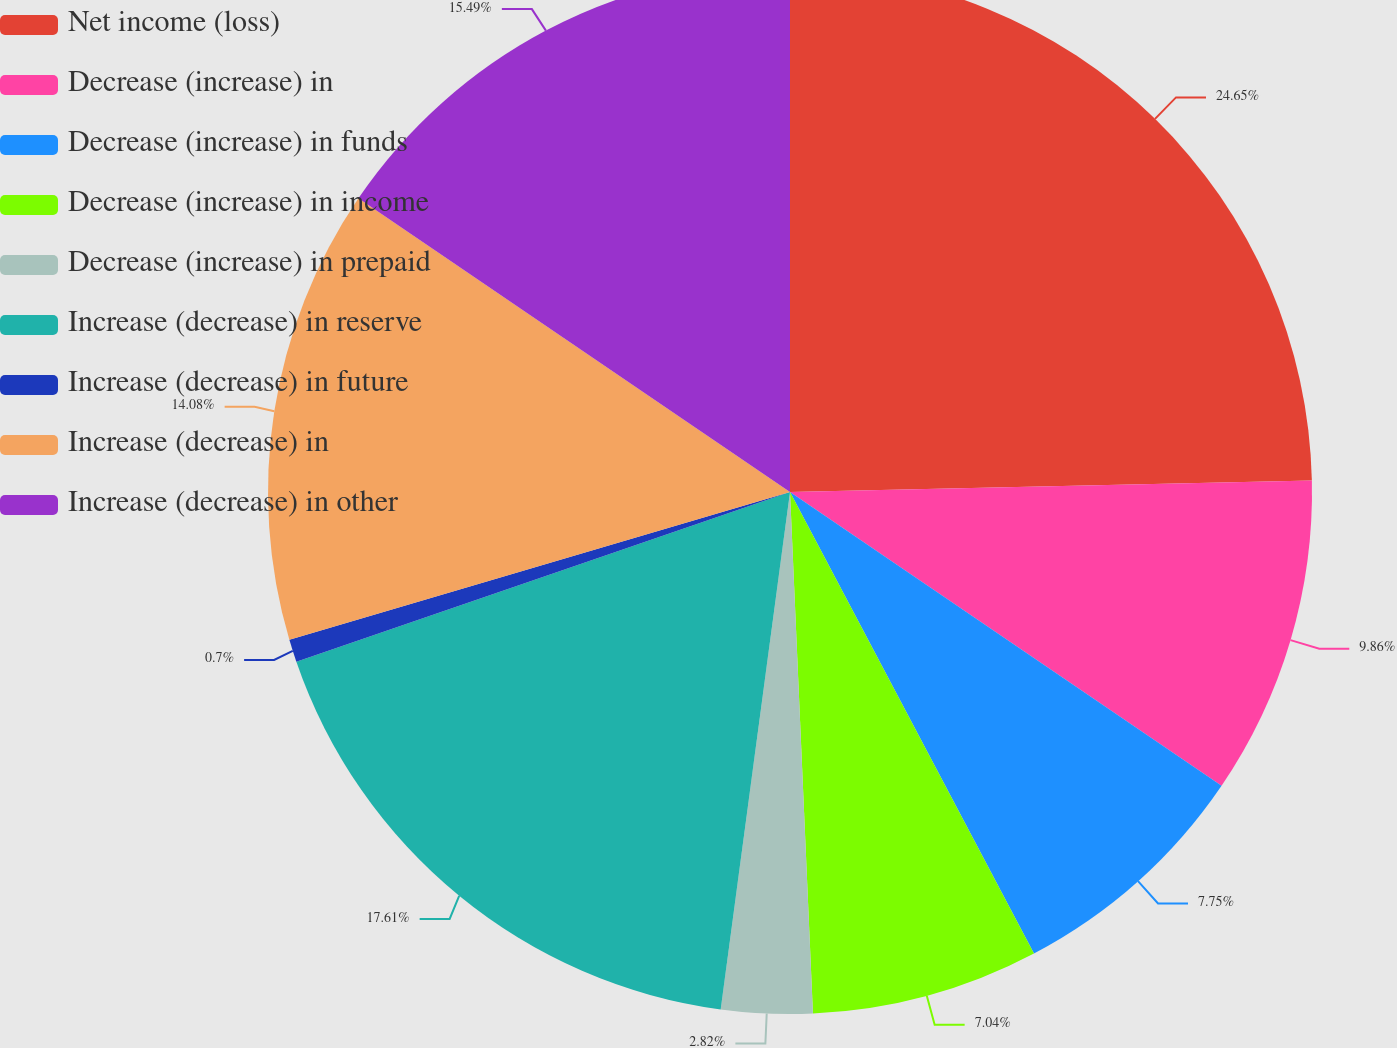Convert chart to OTSL. <chart><loc_0><loc_0><loc_500><loc_500><pie_chart><fcel>Net income (loss)<fcel>Decrease (increase) in<fcel>Decrease (increase) in funds<fcel>Decrease (increase) in income<fcel>Decrease (increase) in prepaid<fcel>Increase (decrease) in reserve<fcel>Increase (decrease) in future<fcel>Increase (decrease) in<fcel>Increase (decrease) in other<nl><fcel>24.65%<fcel>9.86%<fcel>7.75%<fcel>7.04%<fcel>2.82%<fcel>17.61%<fcel>0.7%<fcel>14.08%<fcel>15.49%<nl></chart> 